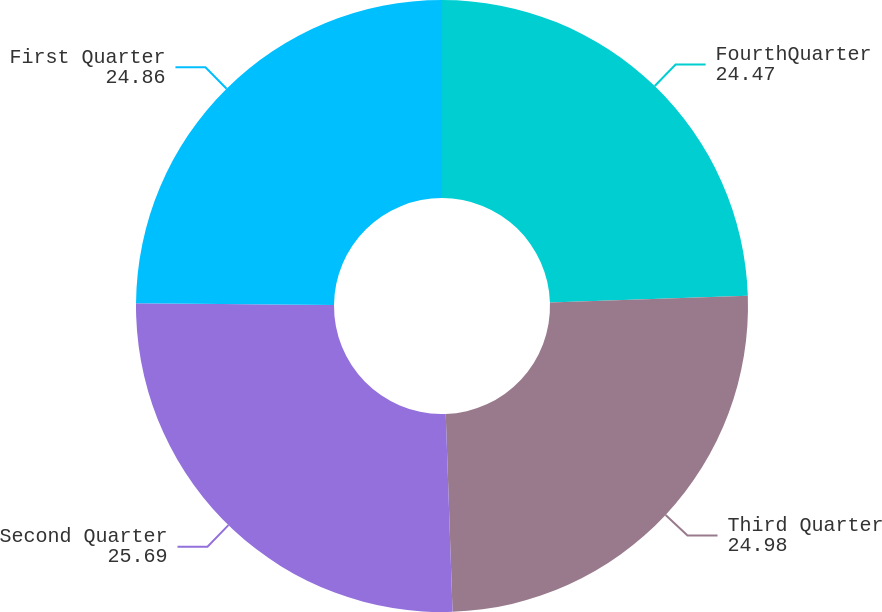Convert chart to OTSL. <chart><loc_0><loc_0><loc_500><loc_500><pie_chart><fcel>FourthQuarter<fcel>Third Quarter<fcel>Second Quarter<fcel>First Quarter<nl><fcel>24.47%<fcel>24.98%<fcel>25.69%<fcel>24.86%<nl></chart> 